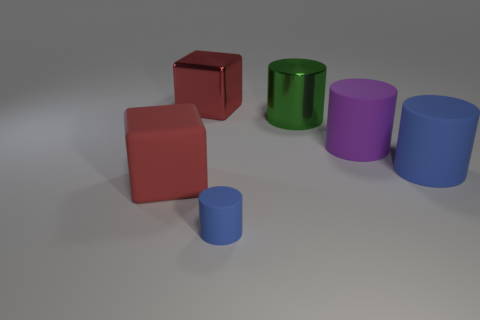The rubber object that is the same color as the metal block is what shape?
Your answer should be compact. Cube. Does the big metallic cube have the same color as the large matte block?
Keep it short and to the point. Yes. What number of blue things are either shiny cylinders or balls?
Your response must be concise. 0. What is the color of the matte cube?
Provide a succinct answer. Red. What is the size of the blue cylinder that is made of the same material as the big blue thing?
Provide a succinct answer. Small. How many green things are the same shape as the large purple thing?
Keep it short and to the point. 1. Are there any other things that have the same size as the green metal thing?
Keep it short and to the point. Yes. There is a matte cylinder that is in front of the big matte object that is to the left of the small matte object; what is its size?
Make the answer very short. Small. There is a purple object that is the same size as the green shiny object; what material is it?
Give a very brief answer. Rubber. Is there a big red block that has the same material as the large purple cylinder?
Give a very brief answer. Yes. 